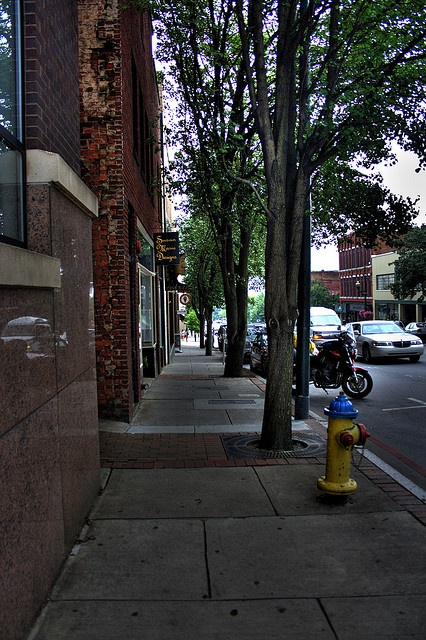Describe the objects in this image and their specific colors. I can see fire hydrant in olive, black, and navy tones, motorcycle in olive, black, white, gray, and navy tones, car in olive, black, white, lightblue, and gray tones, car in olive, white, black, lightblue, and darkgray tones, and car in olive, black, gray, and white tones in this image. 